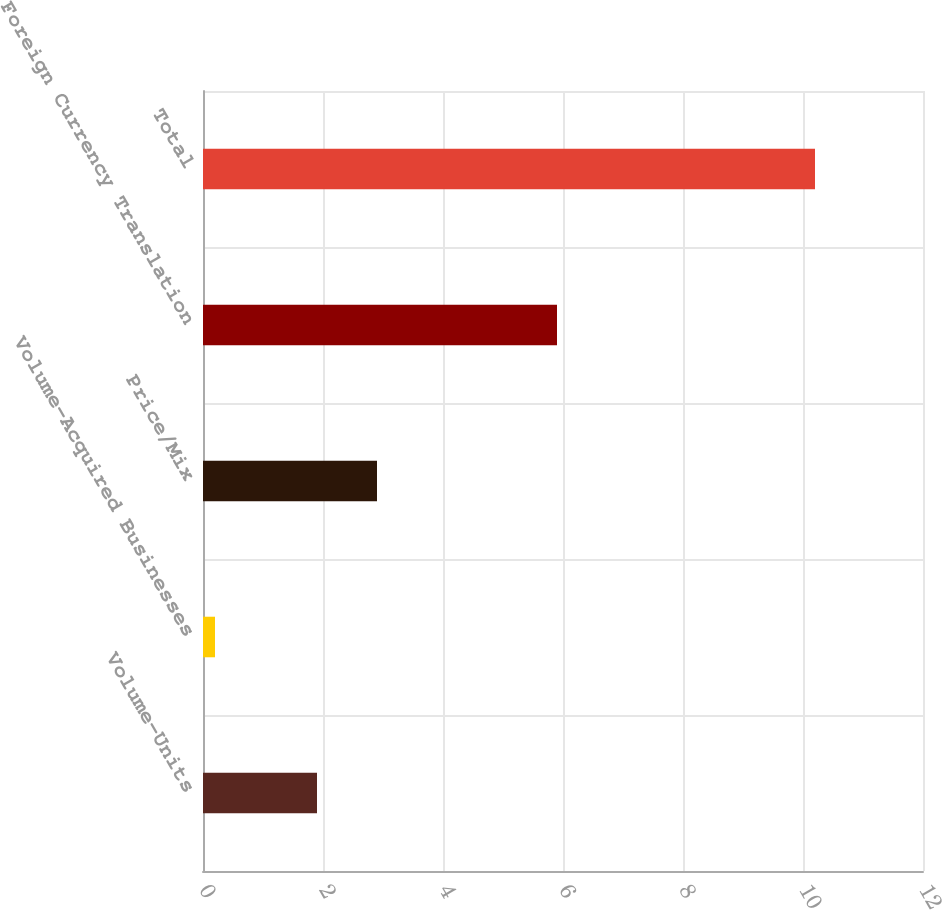Convert chart to OTSL. <chart><loc_0><loc_0><loc_500><loc_500><bar_chart><fcel>Volume-Units<fcel>Volume-Acquired Businesses<fcel>Price/Mix<fcel>Foreign Currency Translation<fcel>Total<nl><fcel>1.9<fcel>0.2<fcel>2.9<fcel>5.9<fcel>10.2<nl></chart> 